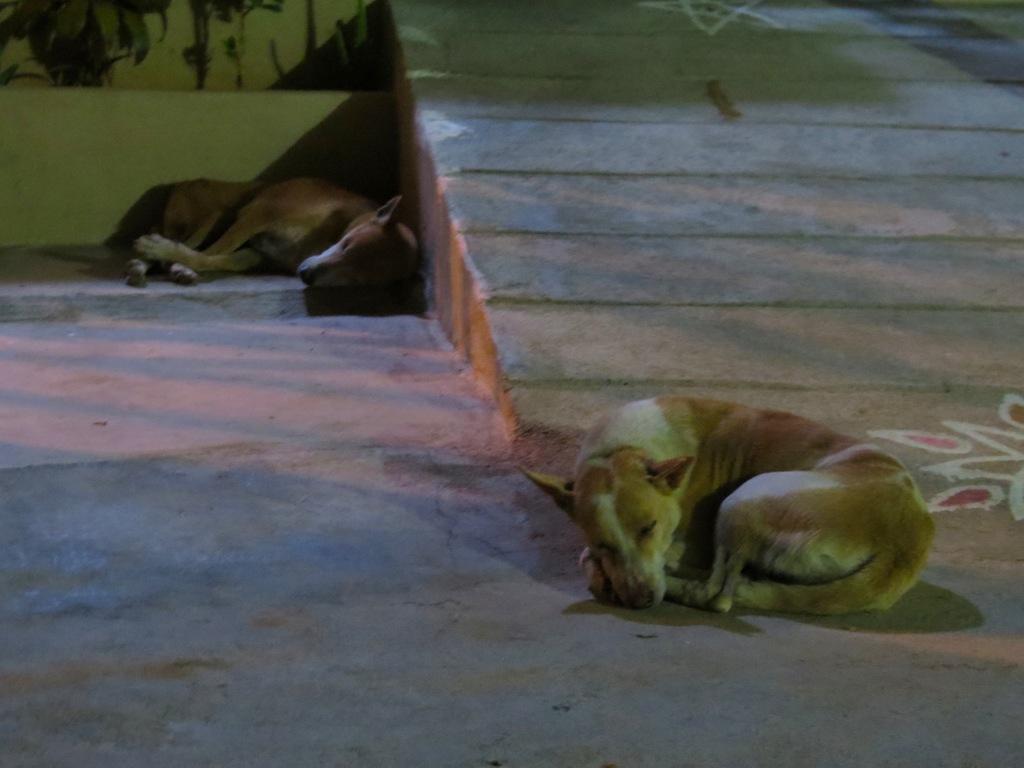Please provide a concise description of this image. This picture is clicked outside and we can see the two dogs sleeping on the ground. In the background we can see the leaves and some other objects. 